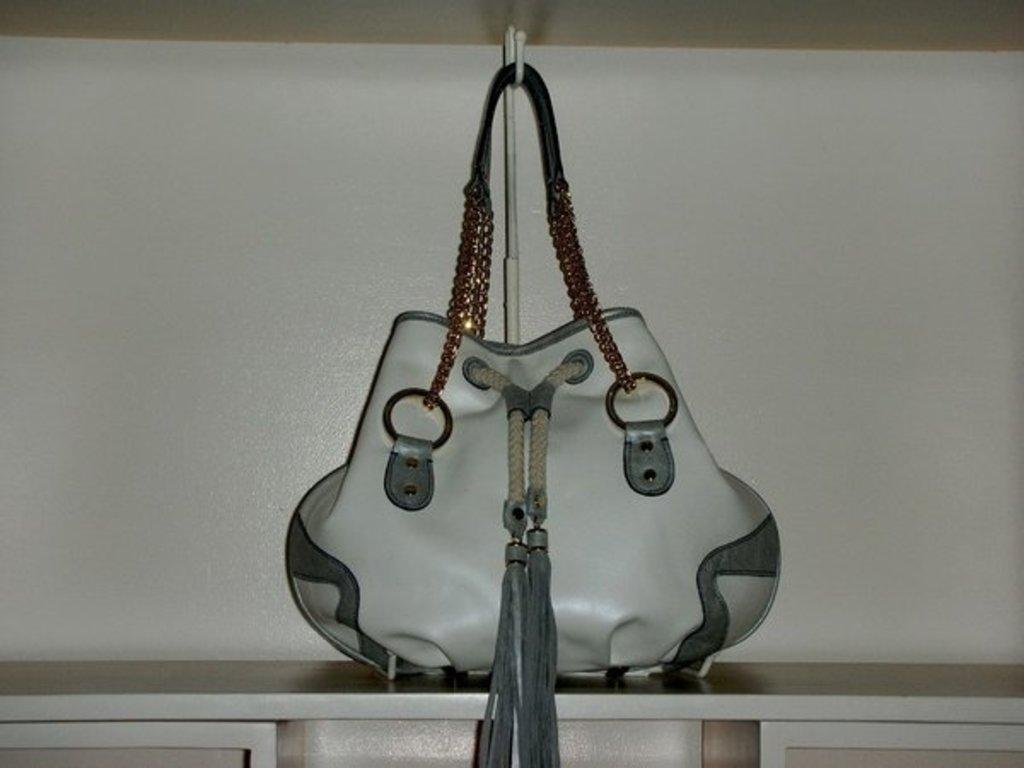What is hanging from a handler in the image? There is a bag with a chain in the image. What color is the bag? The bag is white in color. Where is the bag placed? The bag is placed on a rack. What can be seen in the background of the image? There is a white-colored wall in the background of the image. What type of class is being taught in the image? There is no class or teaching activity depicted in the image; it features a bag hanging from a handler. What caption would best describe the image? The image does not require a caption, as it is a straightforward depiction of a bag hanging from a handler. 